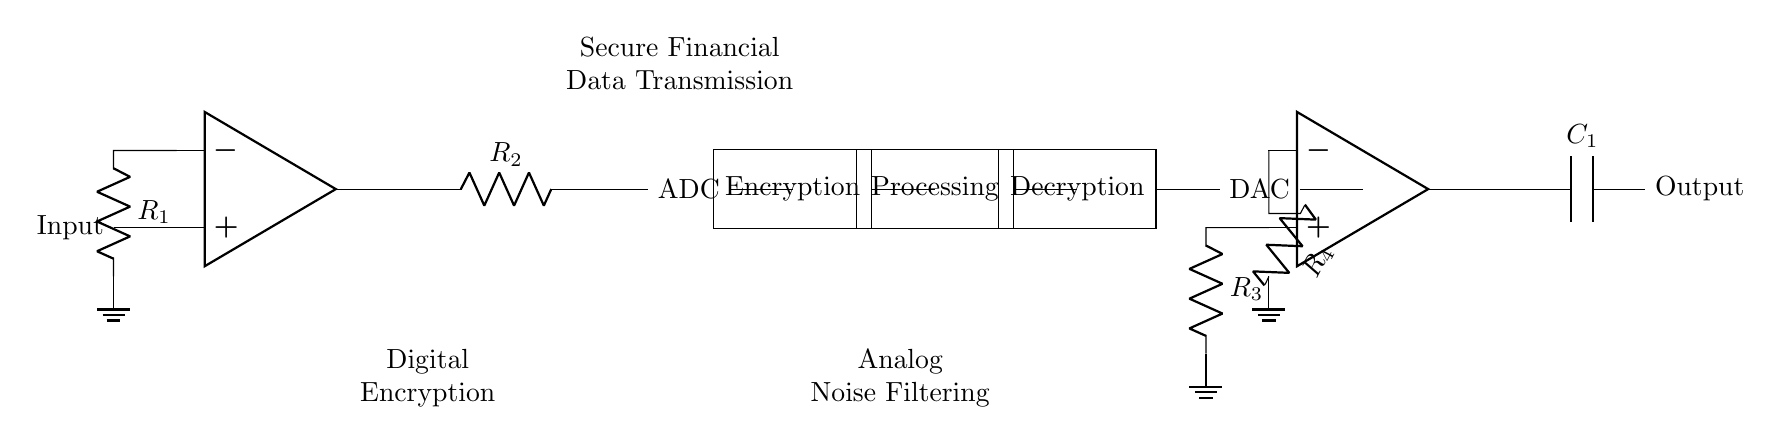What component is used for digital encryption? The component labeled "Encryption" is utilized for digital encryption in the circuit. This stage converts the digital data output from the ADC into an encrypted format.
Answer: Encryption What does the symbol ADC stand for in this circuit? The symbol ADC represents an "Analog to Digital Converter," which is a device that converts the analog input signal into a digital output format for processing.
Answer: Analog to Digital Converter What type of filtering is applied in this circuit? The circuit includes "Analog Noise Filtering," which is performed after the digital-to-analog conversion to minimize noise in the signal.
Answer: Analog Noise Filtering Which resistor is part of the digital encryption section? The resistors in the digital encryption section are labeled "R1" and "R2," indicating their position in the circuit connected to the operational amplifier.
Answer: R1, R2 What is the output component of the analog noise filtering section? The output component of the analog noise filtering section is the capacitor labeled "C1," which helps smooth the output signal after filtering.
Answer: C1 What is the role of the operational amplifier in this hybrid circuit? The operational amplifiers (op amp) are used both in the digital encryption section and the analog noise filtering section to amplify signals which is a crucial function in various stages of the circuit's operations.
Answer: Amplification What does DAC stand for in this circuit? The component labeled "DAC" stands for "Digital to Analog Converter," which converts the encrypted digital signal back into an analog format for further processing or transmission.
Answer: Digital to Analog Converter 